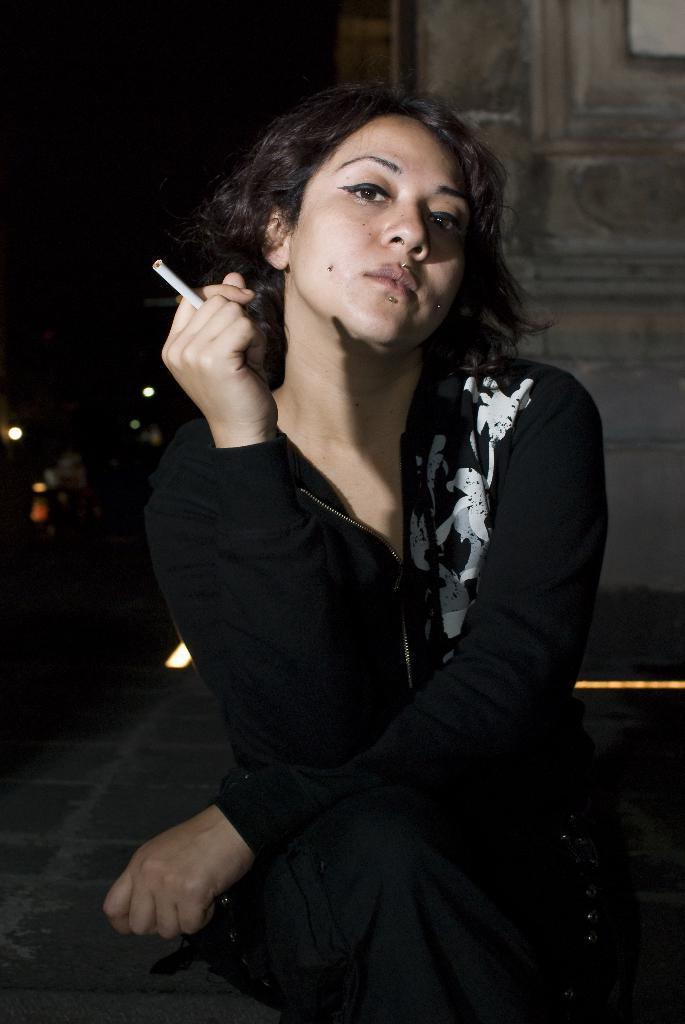What is the main subject in the foreground of the picture? There is a woman sitting in the foreground of the picture. What is the woman wearing? The woman is wearing a black dress. What is the woman holding in the picture? The woman is holding a cigarette. Can you describe the background of the image? The background of the image is blurred, and there are lights and a wall visible. What month is it in the image? The month cannot be determined from the image, as there is no information about the time of year or any seasonal elements present. 